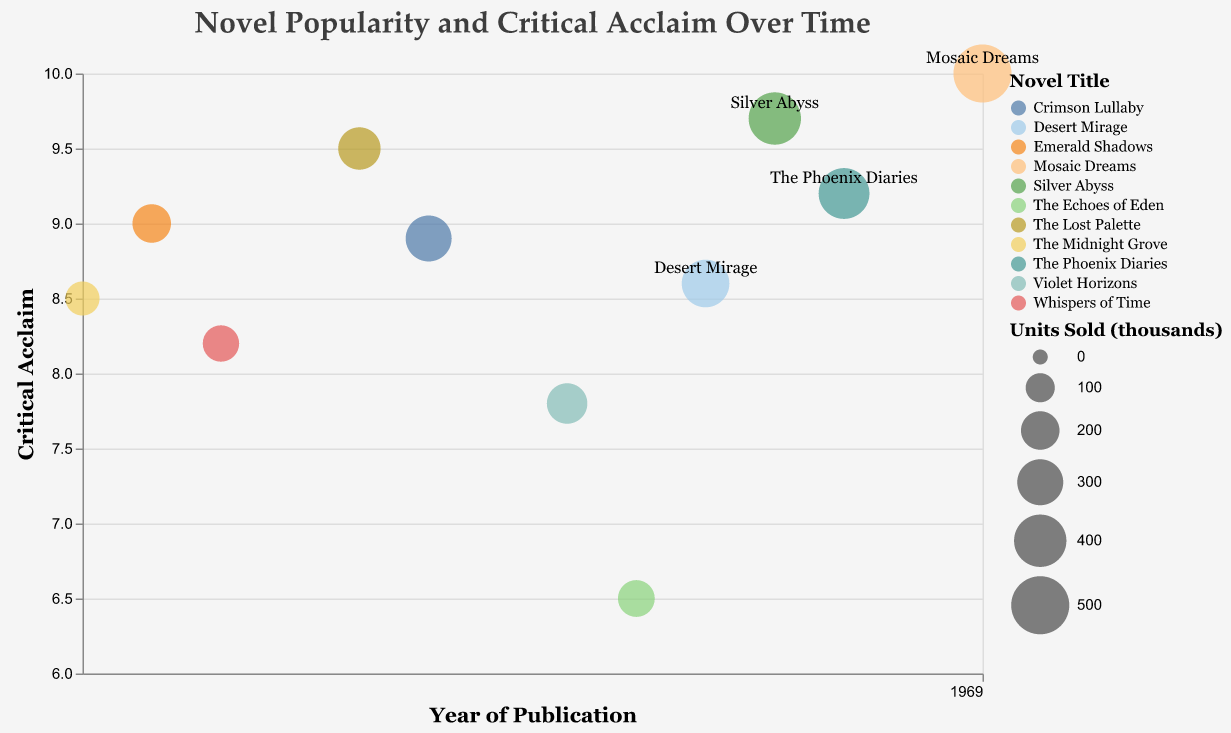How many novels have a critical acclaim score of 9.0 or higher? To determine the number of novels with a critical acclaim score of 9.0 or higher, look at the vertical axis and count the bubbles located at or above the 9.0 mark.
Answer: 5 Which novel has the highest units sold, and what is its critical acclaim score? Find the largest bubble on the chart, note its position along the vertical axis, and check the corresponding score on the y-axis.
Answer: Mosaic Dreams, 10.0 Which year saw the highest critical acclaim? Look for the highest point on the y-axis (10.0) and examine the corresponding x-axis value for the year.
Answer: 2023 What is the average units sold for the novels published between 2015 and 2020? Identify the novels published between 2015 and 2020, sum the units sold for each, and divide by the number of novels in this range: (300 + 225 + 180 + 325 + 400) / 5.
Answer: 286 Is there a trend in critical acclaim over the years? Observe the general direction of the bubbles along the y-axis as you move from left to right (earlier to later years).
Answer: Increasing trend Which novel has the lowest critical acclaim, and in which year was it published? Find the bubble closest to the lowest point on the y-axis (6.5) and note its year on the x-axis.
Answer: The Echoes of Eden, 2018 Are there more novels with critical acclaim above 8.5 or below 8.5? Count the bubbles above the 8.5 line and compare to those below it on the y-axis.
Answer: More above 8.5 How did the units sold trend change for novels with critical acclaim scores from 9.0 to 10.0? Identify the bubbles with acclaim scores from 9.0 to 10.0 and note their size. Compare the sizes to see if they generally increase or decrease.
Answer: Increasing trend Which year featured both high units sold and high critical acclaim? Look for a relatively large bubble positioned at 9.0 or above on the y-axis and note the corresponding year.
Answer: 2023 How many novels published after 2019 have a critical acclaim score below 9.0? Identify the bubbles with publication years after 2019 and count how many are positioned below the 9.0 mark on the y-axis.
Answer: 1 